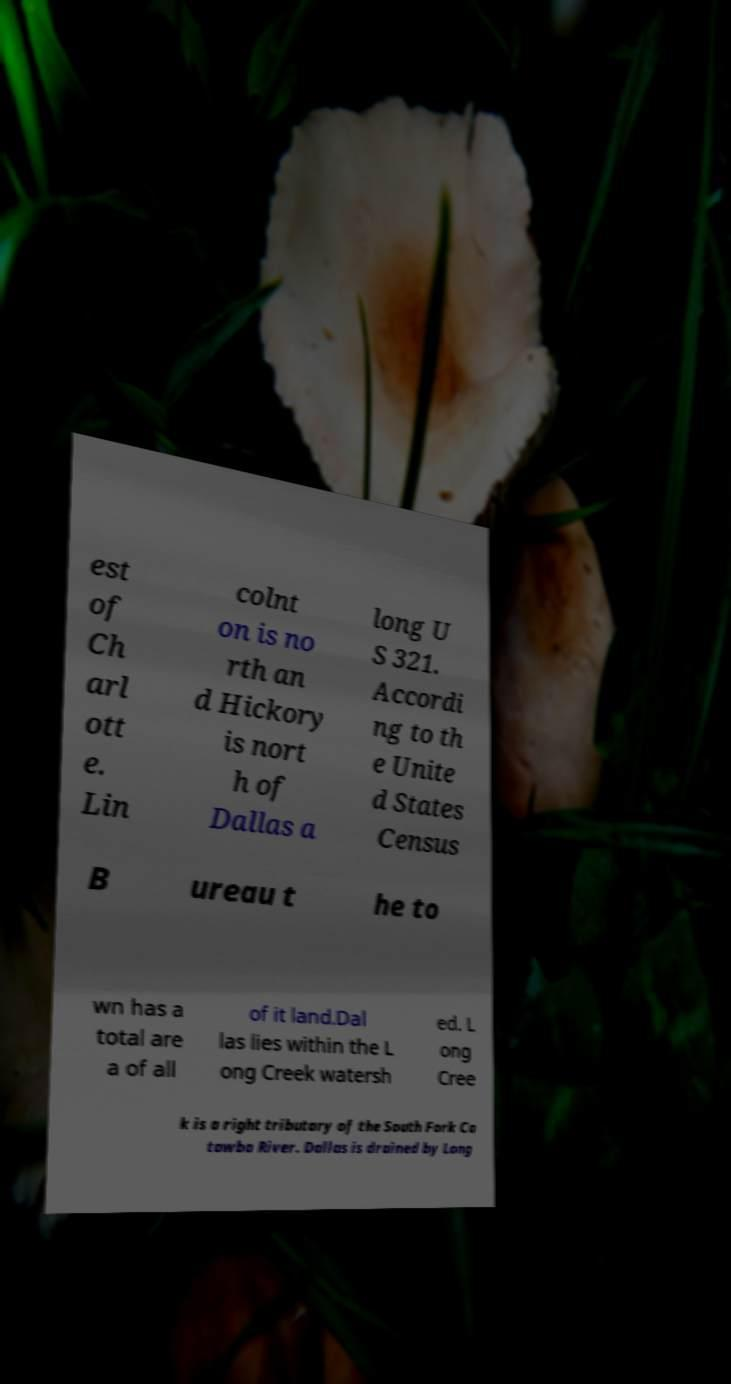Can you accurately transcribe the text from the provided image for me? est of Ch arl ott e. Lin colnt on is no rth an d Hickory is nort h of Dallas a long U S 321. Accordi ng to th e Unite d States Census B ureau t he to wn has a total are a of all of it land.Dal las lies within the L ong Creek watersh ed. L ong Cree k is a right tributary of the South Fork Ca tawba River. Dallas is drained by Long 